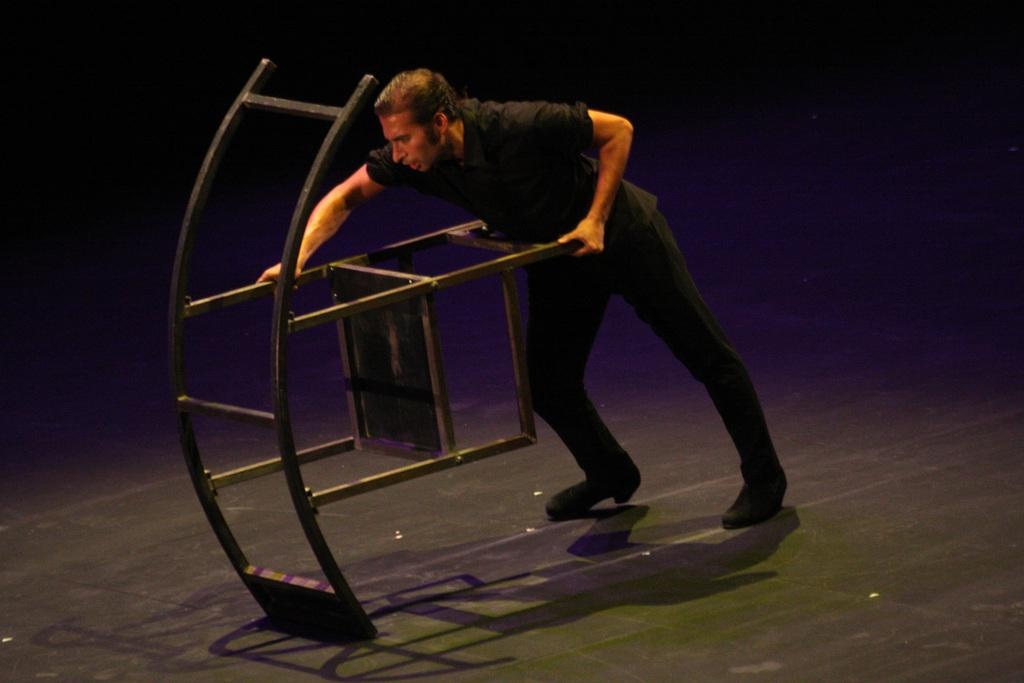What is the main subject of the image? The main subject of the image is a person. What is the person doing in the image? The person is pushing a metal object. Where is the metal object located? The metal object is on a floor. What is the color of the background in the image? The background of the image is dark. How many pies are being carried by the dogs in the image? There are no dogs or pies present in the image. 